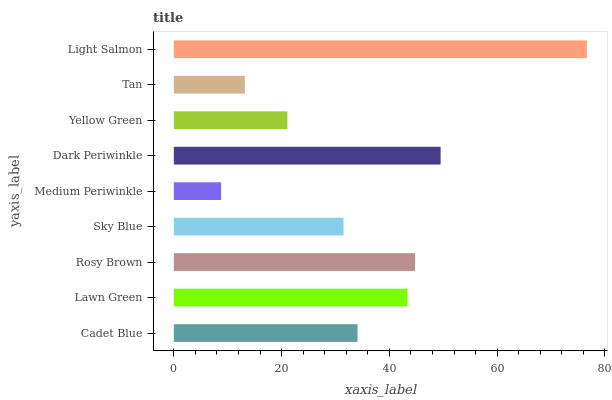Is Medium Periwinkle the minimum?
Answer yes or no. Yes. Is Light Salmon the maximum?
Answer yes or no. Yes. Is Lawn Green the minimum?
Answer yes or no. No. Is Lawn Green the maximum?
Answer yes or no. No. Is Lawn Green greater than Cadet Blue?
Answer yes or no. Yes. Is Cadet Blue less than Lawn Green?
Answer yes or no. Yes. Is Cadet Blue greater than Lawn Green?
Answer yes or no. No. Is Lawn Green less than Cadet Blue?
Answer yes or no. No. Is Cadet Blue the high median?
Answer yes or no. Yes. Is Cadet Blue the low median?
Answer yes or no. Yes. Is Medium Periwinkle the high median?
Answer yes or no. No. Is Tan the low median?
Answer yes or no. No. 